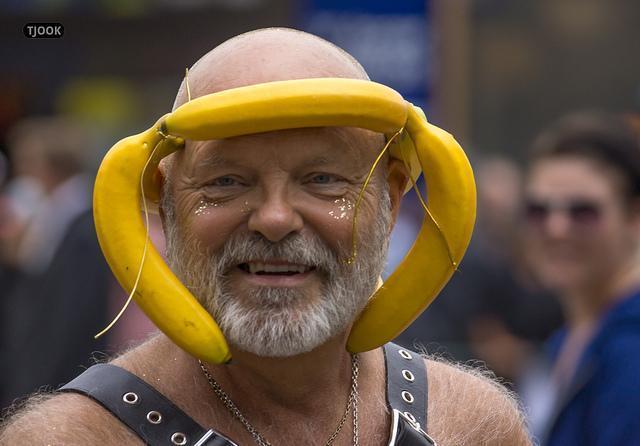How many bananas can you see?
Give a very brief answer. 3. How many people can you see?
Give a very brief answer. 3. 